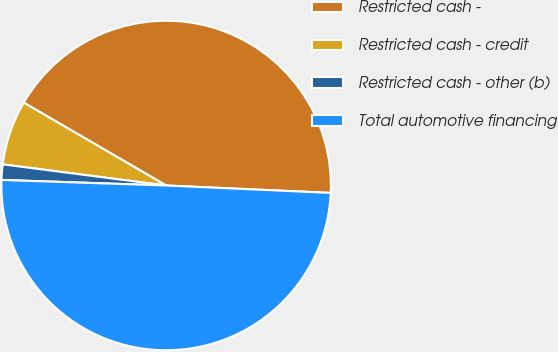Convert chart to OTSL. <chart><loc_0><loc_0><loc_500><loc_500><pie_chart><fcel>Restricted cash -<fcel>Restricted cash - credit<fcel>Restricted cash - other (b)<fcel>Total automotive financing<nl><fcel>42.33%<fcel>6.34%<fcel>1.51%<fcel>49.82%<nl></chart> 